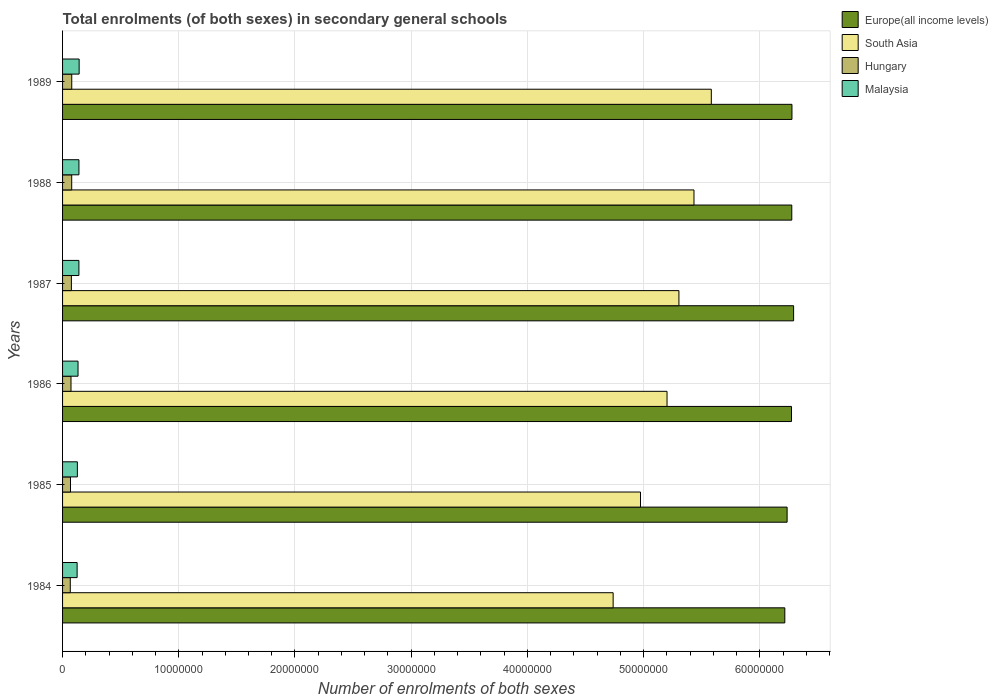What is the label of the 6th group of bars from the top?
Your response must be concise. 1984. In how many cases, is the number of bars for a given year not equal to the number of legend labels?
Offer a terse response. 0. What is the number of enrolments in secondary schools in Hungary in 1988?
Your response must be concise. 7.86e+05. Across all years, what is the maximum number of enrolments in secondary schools in South Asia?
Your answer should be compact. 5.58e+07. Across all years, what is the minimum number of enrolments in secondary schools in Malaysia?
Your answer should be compact. 1.25e+06. In which year was the number of enrolments in secondary schools in Malaysia maximum?
Keep it short and to the point. 1989. In which year was the number of enrolments in secondary schools in Hungary minimum?
Offer a terse response. 1984. What is the total number of enrolments in secondary schools in South Asia in the graph?
Keep it short and to the point. 3.12e+08. What is the difference between the number of enrolments in secondary schools in Hungary in 1984 and that in 1988?
Provide a short and direct response. -1.23e+05. What is the difference between the number of enrolments in secondary schools in Europe(all income levels) in 1987 and the number of enrolments in secondary schools in South Asia in 1985?
Make the answer very short. 1.32e+07. What is the average number of enrolments in secondary schools in Malaysia per year?
Your answer should be compact. 1.35e+06. In the year 1984, what is the difference between the number of enrolments in secondary schools in Hungary and number of enrolments in secondary schools in Europe(all income levels)?
Provide a succinct answer. -6.15e+07. What is the ratio of the number of enrolments in secondary schools in South Asia in 1984 to that in 1988?
Your answer should be compact. 0.87. Is the number of enrolments in secondary schools in South Asia in 1984 less than that in 1987?
Offer a terse response. Yes. What is the difference between the highest and the second highest number of enrolments in secondary schools in Hungary?
Your response must be concise. 3488. What is the difference between the highest and the lowest number of enrolments in secondary schools in Europe(all income levels)?
Your response must be concise. 7.57e+05. Is the sum of the number of enrolments in secondary schools in Malaysia in 1985 and 1989 greater than the maximum number of enrolments in secondary schools in Hungary across all years?
Provide a short and direct response. Yes. Is it the case that in every year, the sum of the number of enrolments in secondary schools in Europe(all income levels) and number of enrolments in secondary schools in South Asia is greater than the sum of number of enrolments in secondary schools in Hungary and number of enrolments in secondary schools in Malaysia?
Your answer should be compact. No. What does the 3rd bar from the top in 1988 represents?
Your answer should be very brief. South Asia. What does the 3rd bar from the bottom in 1989 represents?
Provide a succinct answer. Hungary. Is it the case that in every year, the sum of the number of enrolments in secondary schools in Hungary and number of enrolments in secondary schools in Europe(all income levels) is greater than the number of enrolments in secondary schools in Malaysia?
Make the answer very short. Yes. Where does the legend appear in the graph?
Your answer should be very brief. Top right. How many legend labels are there?
Your answer should be very brief. 4. How are the legend labels stacked?
Give a very brief answer. Vertical. What is the title of the graph?
Give a very brief answer. Total enrolments (of both sexes) in secondary general schools. Does "Romania" appear as one of the legend labels in the graph?
Make the answer very short. No. What is the label or title of the X-axis?
Provide a succinct answer. Number of enrolments of both sexes. What is the Number of enrolments of both sexes of Europe(all income levels) in 1984?
Give a very brief answer. 6.22e+07. What is the Number of enrolments of both sexes of South Asia in 1984?
Keep it short and to the point. 4.74e+07. What is the Number of enrolments of both sexes of Hungary in 1984?
Make the answer very short. 6.63e+05. What is the Number of enrolments of both sexes of Malaysia in 1984?
Your response must be concise. 1.25e+06. What is the Number of enrolments of both sexes of Europe(all income levels) in 1985?
Provide a succinct answer. 6.24e+07. What is the Number of enrolments of both sexes in South Asia in 1985?
Provide a succinct answer. 4.97e+07. What is the Number of enrolments of both sexes in Hungary in 1985?
Offer a terse response. 6.83e+05. What is the Number of enrolments of both sexes in Malaysia in 1985?
Give a very brief answer. 1.27e+06. What is the Number of enrolments of both sexes in Europe(all income levels) in 1986?
Provide a short and direct response. 6.27e+07. What is the Number of enrolments of both sexes in South Asia in 1986?
Provide a short and direct response. 5.20e+07. What is the Number of enrolments of both sexes of Hungary in 1986?
Your response must be concise. 7.26e+05. What is the Number of enrolments of both sexes in Malaysia in 1986?
Make the answer very short. 1.33e+06. What is the Number of enrolments of both sexes in Europe(all income levels) in 1987?
Your response must be concise. 6.29e+07. What is the Number of enrolments of both sexes of South Asia in 1987?
Keep it short and to the point. 5.30e+07. What is the Number of enrolments of both sexes of Hungary in 1987?
Offer a terse response. 7.60e+05. What is the Number of enrolments of both sexes of Malaysia in 1987?
Offer a terse response. 1.41e+06. What is the Number of enrolments of both sexes in Europe(all income levels) in 1988?
Your answer should be compact. 6.28e+07. What is the Number of enrolments of both sexes of South Asia in 1988?
Make the answer very short. 5.43e+07. What is the Number of enrolments of both sexes of Hungary in 1988?
Your answer should be compact. 7.86e+05. What is the Number of enrolments of both sexes of Malaysia in 1988?
Keep it short and to the point. 1.41e+06. What is the Number of enrolments of both sexes of Europe(all income levels) in 1989?
Make the answer very short. 6.28e+07. What is the Number of enrolments of both sexes of South Asia in 1989?
Your response must be concise. 5.58e+07. What is the Number of enrolments of both sexes of Hungary in 1989?
Offer a terse response. 7.90e+05. What is the Number of enrolments of both sexes of Malaysia in 1989?
Your answer should be compact. 1.43e+06. Across all years, what is the maximum Number of enrolments of both sexes in Europe(all income levels)?
Provide a succinct answer. 6.29e+07. Across all years, what is the maximum Number of enrolments of both sexes in South Asia?
Your response must be concise. 5.58e+07. Across all years, what is the maximum Number of enrolments of both sexes of Hungary?
Ensure brevity in your answer.  7.90e+05. Across all years, what is the maximum Number of enrolments of both sexes of Malaysia?
Offer a terse response. 1.43e+06. Across all years, what is the minimum Number of enrolments of both sexes of Europe(all income levels)?
Provide a succinct answer. 6.22e+07. Across all years, what is the minimum Number of enrolments of both sexes of South Asia?
Keep it short and to the point. 4.74e+07. Across all years, what is the minimum Number of enrolments of both sexes of Hungary?
Your response must be concise. 6.63e+05. Across all years, what is the minimum Number of enrolments of both sexes of Malaysia?
Offer a very short reply. 1.25e+06. What is the total Number of enrolments of both sexes of Europe(all income levels) in the graph?
Offer a terse response. 3.76e+08. What is the total Number of enrolments of both sexes of South Asia in the graph?
Offer a terse response. 3.12e+08. What is the total Number of enrolments of both sexes of Hungary in the graph?
Your answer should be compact. 4.41e+06. What is the total Number of enrolments of both sexes of Malaysia in the graph?
Ensure brevity in your answer.  8.10e+06. What is the difference between the Number of enrolments of both sexes of Europe(all income levels) in 1984 and that in 1985?
Offer a terse response. -1.97e+05. What is the difference between the Number of enrolments of both sexes of South Asia in 1984 and that in 1985?
Your answer should be compact. -2.36e+06. What is the difference between the Number of enrolments of both sexes of Hungary in 1984 and that in 1985?
Ensure brevity in your answer.  -1.94e+04. What is the difference between the Number of enrolments of both sexes in Malaysia in 1984 and that in 1985?
Your answer should be very brief. -2.15e+04. What is the difference between the Number of enrolments of both sexes of Europe(all income levels) in 1984 and that in 1986?
Your answer should be compact. -5.74e+05. What is the difference between the Number of enrolments of both sexes of South Asia in 1984 and that in 1986?
Your answer should be very brief. -4.64e+06. What is the difference between the Number of enrolments of both sexes in Hungary in 1984 and that in 1986?
Make the answer very short. -6.28e+04. What is the difference between the Number of enrolments of both sexes of Malaysia in 1984 and that in 1986?
Make the answer very short. -7.76e+04. What is the difference between the Number of enrolments of both sexes in Europe(all income levels) in 1984 and that in 1987?
Offer a terse response. -7.57e+05. What is the difference between the Number of enrolments of both sexes in South Asia in 1984 and that in 1987?
Give a very brief answer. -5.66e+06. What is the difference between the Number of enrolments of both sexes of Hungary in 1984 and that in 1987?
Offer a terse response. -9.64e+04. What is the difference between the Number of enrolments of both sexes of Malaysia in 1984 and that in 1987?
Provide a succinct answer. -1.53e+05. What is the difference between the Number of enrolments of both sexes in Europe(all income levels) in 1984 and that in 1988?
Provide a succinct answer. -5.99e+05. What is the difference between the Number of enrolments of both sexes in South Asia in 1984 and that in 1988?
Offer a very short reply. -6.96e+06. What is the difference between the Number of enrolments of both sexes in Hungary in 1984 and that in 1988?
Your answer should be compact. -1.23e+05. What is the difference between the Number of enrolments of both sexes in Malaysia in 1984 and that in 1988?
Your response must be concise. -1.56e+05. What is the difference between the Number of enrolments of both sexes of Europe(all income levels) in 1984 and that in 1989?
Give a very brief answer. -6.14e+05. What is the difference between the Number of enrolments of both sexes of South Asia in 1984 and that in 1989?
Give a very brief answer. -8.45e+06. What is the difference between the Number of enrolments of both sexes of Hungary in 1984 and that in 1989?
Your answer should be very brief. -1.26e+05. What is the difference between the Number of enrolments of both sexes in Malaysia in 1984 and that in 1989?
Ensure brevity in your answer.  -1.73e+05. What is the difference between the Number of enrolments of both sexes of Europe(all income levels) in 1985 and that in 1986?
Your answer should be compact. -3.78e+05. What is the difference between the Number of enrolments of both sexes in South Asia in 1985 and that in 1986?
Make the answer very short. -2.28e+06. What is the difference between the Number of enrolments of both sexes of Hungary in 1985 and that in 1986?
Your answer should be very brief. -4.35e+04. What is the difference between the Number of enrolments of both sexes of Malaysia in 1985 and that in 1986?
Provide a short and direct response. -5.61e+04. What is the difference between the Number of enrolments of both sexes of Europe(all income levels) in 1985 and that in 1987?
Offer a very short reply. -5.60e+05. What is the difference between the Number of enrolments of both sexes of South Asia in 1985 and that in 1987?
Your response must be concise. -3.31e+06. What is the difference between the Number of enrolments of both sexes in Hungary in 1985 and that in 1987?
Provide a succinct answer. -7.71e+04. What is the difference between the Number of enrolments of both sexes in Malaysia in 1985 and that in 1987?
Your answer should be very brief. -1.32e+05. What is the difference between the Number of enrolments of both sexes in Europe(all income levels) in 1985 and that in 1988?
Offer a very short reply. -4.03e+05. What is the difference between the Number of enrolments of both sexes in South Asia in 1985 and that in 1988?
Your answer should be very brief. -4.60e+06. What is the difference between the Number of enrolments of both sexes in Hungary in 1985 and that in 1988?
Your response must be concise. -1.04e+05. What is the difference between the Number of enrolments of both sexes in Malaysia in 1985 and that in 1988?
Your answer should be compact. -1.34e+05. What is the difference between the Number of enrolments of both sexes in Europe(all income levels) in 1985 and that in 1989?
Keep it short and to the point. -4.17e+05. What is the difference between the Number of enrolments of both sexes of South Asia in 1985 and that in 1989?
Provide a succinct answer. -6.09e+06. What is the difference between the Number of enrolments of both sexes in Hungary in 1985 and that in 1989?
Ensure brevity in your answer.  -1.07e+05. What is the difference between the Number of enrolments of both sexes of Malaysia in 1985 and that in 1989?
Your response must be concise. -1.52e+05. What is the difference between the Number of enrolments of both sexes in Europe(all income levels) in 1986 and that in 1987?
Your answer should be compact. -1.82e+05. What is the difference between the Number of enrolments of both sexes in South Asia in 1986 and that in 1987?
Keep it short and to the point. -1.02e+06. What is the difference between the Number of enrolments of both sexes in Hungary in 1986 and that in 1987?
Your response must be concise. -3.36e+04. What is the difference between the Number of enrolments of both sexes in Malaysia in 1986 and that in 1987?
Provide a short and direct response. -7.59e+04. What is the difference between the Number of enrolments of both sexes of Europe(all income levels) in 1986 and that in 1988?
Make the answer very short. -2.49e+04. What is the difference between the Number of enrolments of both sexes in South Asia in 1986 and that in 1988?
Your answer should be compact. -2.32e+06. What is the difference between the Number of enrolments of both sexes of Hungary in 1986 and that in 1988?
Offer a terse response. -6.00e+04. What is the difference between the Number of enrolments of both sexes in Malaysia in 1986 and that in 1988?
Make the answer very short. -7.83e+04. What is the difference between the Number of enrolments of both sexes of Europe(all income levels) in 1986 and that in 1989?
Your response must be concise. -3.92e+04. What is the difference between the Number of enrolments of both sexes of South Asia in 1986 and that in 1989?
Your answer should be very brief. -3.81e+06. What is the difference between the Number of enrolments of both sexes of Hungary in 1986 and that in 1989?
Offer a terse response. -6.35e+04. What is the difference between the Number of enrolments of both sexes of Malaysia in 1986 and that in 1989?
Offer a terse response. -9.56e+04. What is the difference between the Number of enrolments of both sexes of Europe(all income levels) in 1987 and that in 1988?
Your answer should be very brief. 1.58e+05. What is the difference between the Number of enrolments of both sexes in South Asia in 1987 and that in 1988?
Provide a succinct answer. -1.30e+06. What is the difference between the Number of enrolments of both sexes in Hungary in 1987 and that in 1988?
Ensure brevity in your answer.  -2.64e+04. What is the difference between the Number of enrolments of both sexes in Malaysia in 1987 and that in 1988?
Provide a succinct answer. -2446. What is the difference between the Number of enrolments of both sexes in Europe(all income levels) in 1987 and that in 1989?
Offer a very short reply. 1.43e+05. What is the difference between the Number of enrolments of both sexes in South Asia in 1987 and that in 1989?
Offer a terse response. -2.79e+06. What is the difference between the Number of enrolments of both sexes of Hungary in 1987 and that in 1989?
Make the answer very short. -2.99e+04. What is the difference between the Number of enrolments of both sexes in Malaysia in 1987 and that in 1989?
Your answer should be compact. -1.97e+04. What is the difference between the Number of enrolments of both sexes of Europe(all income levels) in 1988 and that in 1989?
Give a very brief answer. -1.42e+04. What is the difference between the Number of enrolments of both sexes in South Asia in 1988 and that in 1989?
Make the answer very short. -1.49e+06. What is the difference between the Number of enrolments of both sexes of Hungary in 1988 and that in 1989?
Keep it short and to the point. -3488. What is the difference between the Number of enrolments of both sexes of Malaysia in 1988 and that in 1989?
Give a very brief answer. -1.73e+04. What is the difference between the Number of enrolments of both sexes in Europe(all income levels) in 1984 and the Number of enrolments of both sexes in South Asia in 1985?
Your answer should be compact. 1.24e+07. What is the difference between the Number of enrolments of both sexes of Europe(all income levels) in 1984 and the Number of enrolments of both sexes of Hungary in 1985?
Keep it short and to the point. 6.15e+07. What is the difference between the Number of enrolments of both sexes of Europe(all income levels) in 1984 and the Number of enrolments of both sexes of Malaysia in 1985?
Offer a terse response. 6.09e+07. What is the difference between the Number of enrolments of both sexes in South Asia in 1984 and the Number of enrolments of both sexes in Hungary in 1985?
Your answer should be compact. 4.67e+07. What is the difference between the Number of enrolments of both sexes in South Asia in 1984 and the Number of enrolments of both sexes in Malaysia in 1985?
Provide a succinct answer. 4.61e+07. What is the difference between the Number of enrolments of both sexes in Hungary in 1984 and the Number of enrolments of both sexes in Malaysia in 1985?
Provide a succinct answer. -6.11e+05. What is the difference between the Number of enrolments of both sexes of Europe(all income levels) in 1984 and the Number of enrolments of both sexes of South Asia in 1986?
Provide a succinct answer. 1.01e+07. What is the difference between the Number of enrolments of both sexes of Europe(all income levels) in 1984 and the Number of enrolments of both sexes of Hungary in 1986?
Make the answer very short. 6.14e+07. What is the difference between the Number of enrolments of both sexes of Europe(all income levels) in 1984 and the Number of enrolments of both sexes of Malaysia in 1986?
Your answer should be very brief. 6.08e+07. What is the difference between the Number of enrolments of both sexes of South Asia in 1984 and the Number of enrolments of both sexes of Hungary in 1986?
Offer a terse response. 4.67e+07. What is the difference between the Number of enrolments of both sexes in South Asia in 1984 and the Number of enrolments of both sexes in Malaysia in 1986?
Your response must be concise. 4.61e+07. What is the difference between the Number of enrolments of both sexes of Hungary in 1984 and the Number of enrolments of both sexes of Malaysia in 1986?
Offer a terse response. -6.67e+05. What is the difference between the Number of enrolments of both sexes in Europe(all income levels) in 1984 and the Number of enrolments of both sexes in South Asia in 1987?
Make the answer very short. 9.11e+06. What is the difference between the Number of enrolments of both sexes in Europe(all income levels) in 1984 and the Number of enrolments of both sexes in Hungary in 1987?
Provide a succinct answer. 6.14e+07. What is the difference between the Number of enrolments of both sexes in Europe(all income levels) in 1984 and the Number of enrolments of both sexes in Malaysia in 1987?
Provide a short and direct response. 6.07e+07. What is the difference between the Number of enrolments of both sexes of South Asia in 1984 and the Number of enrolments of both sexes of Hungary in 1987?
Your answer should be very brief. 4.66e+07. What is the difference between the Number of enrolments of both sexes in South Asia in 1984 and the Number of enrolments of both sexes in Malaysia in 1987?
Provide a succinct answer. 4.60e+07. What is the difference between the Number of enrolments of both sexes of Hungary in 1984 and the Number of enrolments of both sexes of Malaysia in 1987?
Ensure brevity in your answer.  -7.43e+05. What is the difference between the Number of enrolments of both sexes in Europe(all income levels) in 1984 and the Number of enrolments of both sexes in South Asia in 1988?
Offer a terse response. 7.82e+06. What is the difference between the Number of enrolments of both sexes in Europe(all income levels) in 1984 and the Number of enrolments of both sexes in Hungary in 1988?
Give a very brief answer. 6.14e+07. What is the difference between the Number of enrolments of both sexes of Europe(all income levels) in 1984 and the Number of enrolments of both sexes of Malaysia in 1988?
Offer a terse response. 6.07e+07. What is the difference between the Number of enrolments of both sexes of South Asia in 1984 and the Number of enrolments of both sexes of Hungary in 1988?
Your answer should be very brief. 4.66e+07. What is the difference between the Number of enrolments of both sexes in South Asia in 1984 and the Number of enrolments of both sexes in Malaysia in 1988?
Provide a short and direct response. 4.60e+07. What is the difference between the Number of enrolments of both sexes of Hungary in 1984 and the Number of enrolments of both sexes of Malaysia in 1988?
Your answer should be very brief. -7.45e+05. What is the difference between the Number of enrolments of both sexes in Europe(all income levels) in 1984 and the Number of enrolments of both sexes in South Asia in 1989?
Keep it short and to the point. 6.33e+06. What is the difference between the Number of enrolments of both sexes in Europe(all income levels) in 1984 and the Number of enrolments of both sexes in Hungary in 1989?
Ensure brevity in your answer.  6.14e+07. What is the difference between the Number of enrolments of both sexes in Europe(all income levels) in 1984 and the Number of enrolments of both sexes in Malaysia in 1989?
Your response must be concise. 6.07e+07. What is the difference between the Number of enrolments of both sexes of South Asia in 1984 and the Number of enrolments of both sexes of Hungary in 1989?
Provide a short and direct response. 4.66e+07. What is the difference between the Number of enrolments of both sexes in South Asia in 1984 and the Number of enrolments of both sexes in Malaysia in 1989?
Ensure brevity in your answer.  4.60e+07. What is the difference between the Number of enrolments of both sexes of Hungary in 1984 and the Number of enrolments of both sexes of Malaysia in 1989?
Keep it short and to the point. -7.63e+05. What is the difference between the Number of enrolments of both sexes in Europe(all income levels) in 1985 and the Number of enrolments of both sexes in South Asia in 1986?
Provide a short and direct response. 1.03e+07. What is the difference between the Number of enrolments of both sexes in Europe(all income levels) in 1985 and the Number of enrolments of both sexes in Hungary in 1986?
Give a very brief answer. 6.16e+07. What is the difference between the Number of enrolments of both sexes in Europe(all income levels) in 1985 and the Number of enrolments of both sexes in Malaysia in 1986?
Your answer should be very brief. 6.10e+07. What is the difference between the Number of enrolments of both sexes of South Asia in 1985 and the Number of enrolments of both sexes of Hungary in 1986?
Provide a short and direct response. 4.90e+07. What is the difference between the Number of enrolments of both sexes of South Asia in 1985 and the Number of enrolments of both sexes of Malaysia in 1986?
Make the answer very short. 4.84e+07. What is the difference between the Number of enrolments of both sexes in Hungary in 1985 and the Number of enrolments of both sexes in Malaysia in 1986?
Offer a very short reply. -6.48e+05. What is the difference between the Number of enrolments of both sexes in Europe(all income levels) in 1985 and the Number of enrolments of both sexes in South Asia in 1987?
Offer a very short reply. 9.31e+06. What is the difference between the Number of enrolments of both sexes in Europe(all income levels) in 1985 and the Number of enrolments of both sexes in Hungary in 1987?
Provide a short and direct response. 6.16e+07. What is the difference between the Number of enrolments of both sexes of Europe(all income levels) in 1985 and the Number of enrolments of both sexes of Malaysia in 1987?
Make the answer very short. 6.09e+07. What is the difference between the Number of enrolments of both sexes of South Asia in 1985 and the Number of enrolments of both sexes of Hungary in 1987?
Ensure brevity in your answer.  4.90e+07. What is the difference between the Number of enrolments of both sexes in South Asia in 1985 and the Number of enrolments of both sexes in Malaysia in 1987?
Give a very brief answer. 4.83e+07. What is the difference between the Number of enrolments of both sexes of Hungary in 1985 and the Number of enrolments of both sexes of Malaysia in 1987?
Your answer should be very brief. -7.23e+05. What is the difference between the Number of enrolments of both sexes of Europe(all income levels) in 1985 and the Number of enrolments of both sexes of South Asia in 1988?
Keep it short and to the point. 8.01e+06. What is the difference between the Number of enrolments of both sexes of Europe(all income levels) in 1985 and the Number of enrolments of both sexes of Hungary in 1988?
Keep it short and to the point. 6.16e+07. What is the difference between the Number of enrolments of both sexes of Europe(all income levels) in 1985 and the Number of enrolments of both sexes of Malaysia in 1988?
Give a very brief answer. 6.09e+07. What is the difference between the Number of enrolments of both sexes of South Asia in 1985 and the Number of enrolments of both sexes of Hungary in 1988?
Provide a short and direct response. 4.90e+07. What is the difference between the Number of enrolments of both sexes in South Asia in 1985 and the Number of enrolments of both sexes in Malaysia in 1988?
Offer a terse response. 4.83e+07. What is the difference between the Number of enrolments of both sexes of Hungary in 1985 and the Number of enrolments of both sexes of Malaysia in 1988?
Provide a succinct answer. -7.26e+05. What is the difference between the Number of enrolments of both sexes in Europe(all income levels) in 1985 and the Number of enrolments of both sexes in South Asia in 1989?
Ensure brevity in your answer.  6.52e+06. What is the difference between the Number of enrolments of both sexes in Europe(all income levels) in 1985 and the Number of enrolments of both sexes in Hungary in 1989?
Give a very brief answer. 6.16e+07. What is the difference between the Number of enrolments of both sexes of Europe(all income levels) in 1985 and the Number of enrolments of both sexes of Malaysia in 1989?
Provide a succinct answer. 6.09e+07. What is the difference between the Number of enrolments of both sexes in South Asia in 1985 and the Number of enrolments of both sexes in Hungary in 1989?
Keep it short and to the point. 4.89e+07. What is the difference between the Number of enrolments of both sexes in South Asia in 1985 and the Number of enrolments of both sexes in Malaysia in 1989?
Provide a succinct answer. 4.83e+07. What is the difference between the Number of enrolments of both sexes of Hungary in 1985 and the Number of enrolments of both sexes of Malaysia in 1989?
Keep it short and to the point. -7.43e+05. What is the difference between the Number of enrolments of both sexes of Europe(all income levels) in 1986 and the Number of enrolments of both sexes of South Asia in 1987?
Ensure brevity in your answer.  9.69e+06. What is the difference between the Number of enrolments of both sexes of Europe(all income levels) in 1986 and the Number of enrolments of both sexes of Hungary in 1987?
Provide a succinct answer. 6.20e+07. What is the difference between the Number of enrolments of both sexes in Europe(all income levels) in 1986 and the Number of enrolments of both sexes in Malaysia in 1987?
Provide a succinct answer. 6.13e+07. What is the difference between the Number of enrolments of both sexes of South Asia in 1986 and the Number of enrolments of both sexes of Hungary in 1987?
Provide a succinct answer. 5.13e+07. What is the difference between the Number of enrolments of both sexes of South Asia in 1986 and the Number of enrolments of both sexes of Malaysia in 1987?
Keep it short and to the point. 5.06e+07. What is the difference between the Number of enrolments of both sexes in Hungary in 1986 and the Number of enrolments of both sexes in Malaysia in 1987?
Make the answer very short. -6.80e+05. What is the difference between the Number of enrolments of both sexes of Europe(all income levels) in 1986 and the Number of enrolments of both sexes of South Asia in 1988?
Offer a very short reply. 8.39e+06. What is the difference between the Number of enrolments of both sexes in Europe(all income levels) in 1986 and the Number of enrolments of both sexes in Hungary in 1988?
Provide a succinct answer. 6.19e+07. What is the difference between the Number of enrolments of both sexes in Europe(all income levels) in 1986 and the Number of enrolments of both sexes in Malaysia in 1988?
Provide a succinct answer. 6.13e+07. What is the difference between the Number of enrolments of both sexes of South Asia in 1986 and the Number of enrolments of both sexes of Hungary in 1988?
Keep it short and to the point. 5.12e+07. What is the difference between the Number of enrolments of both sexes in South Asia in 1986 and the Number of enrolments of both sexes in Malaysia in 1988?
Ensure brevity in your answer.  5.06e+07. What is the difference between the Number of enrolments of both sexes in Hungary in 1986 and the Number of enrolments of both sexes in Malaysia in 1988?
Your response must be concise. -6.82e+05. What is the difference between the Number of enrolments of both sexes of Europe(all income levels) in 1986 and the Number of enrolments of both sexes of South Asia in 1989?
Give a very brief answer. 6.90e+06. What is the difference between the Number of enrolments of both sexes of Europe(all income levels) in 1986 and the Number of enrolments of both sexes of Hungary in 1989?
Your answer should be compact. 6.19e+07. What is the difference between the Number of enrolments of both sexes in Europe(all income levels) in 1986 and the Number of enrolments of both sexes in Malaysia in 1989?
Ensure brevity in your answer.  6.13e+07. What is the difference between the Number of enrolments of both sexes in South Asia in 1986 and the Number of enrolments of both sexes in Hungary in 1989?
Offer a very short reply. 5.12e+07. What is the difference between the Number of enrolments of both sexes in South Asia in 1986 and the Number of enrolments of both sexes in Malaysia in 1989?
Provide a short and direct response. 5.06e+07. What is the difference between the Number of enrolments of both sexes of Hungary in 1986 and the Number of enrolments of both sexes of Malaysia in 1989?
Provide a succinct answer. -7.00e+05. What is the difference between the Number of enrolments of both sexes of Europe(all income levels) in 1987 and the Number of enrolments of both sexes of South Asia in 1988?
Ensure brevity in your answer.  8.57e+06. What is the difference between the Number of enrolments of both sexes in Europe(all income levels) in 1987 and the Number of enrolments of both sexes in Hungary in 1988?
Your response must be concise. 6.21e+07. What is the difference between the Number of enrolments of both sexes in Europe(all income levels) in 1987 and the Number of enrolments of both sexes in Malaysia in 1988?
Offer a terse response. 6.15e+07. What is the difference between the Number of enrolments of both sexes in South Asia in 1987 and the Number of enrolments of both sexes in Hungary in 1988?
Provide a succinct answer. 5.23e+07. What is the difference between the Number of enrolments of both sexes of South Asia in 1987 and the Number of enrolments of both sexes of Malaysia in 1988?
Make the answer very short. 5.16e+07. What is the difference between the Number of enrolments of both sexes in Hungary in 1987 and the Number of enrolments of both sexes in Malaysia in 1988?
Your response must be concise. -6.49e+05. What is the difference between the Number of enrolments of both sexes of Europe(all income levels) in 1987 and the Number of enrolments of both sexes of South Asia in 1989?
Your answer should be compact. 7.08e+06. What is the difference between the Number of enrolments of both sexes of Europe(all income levels) in 1987 and the Number of enrolments of both sexes of Hungary in 1989?
Ensure brevity in your answer.  6.21e+07. What is the difference between the Number of enrolments of both sexes in Europe(all income levels) in 1987 and the Number of enrolments of both sexes in Malaysia in 1989?
Provide a short and direct response. 6.15e+07. What is the difference between the Number of enrolments of both sexes in South Asia in 1987 and the Number of enrolments of both sexes in Hungary in 1989?
Give a very brief answer. 5.23e+07. What is the difference between the Number of enrolments of both sexes of South Asia in 1987 and the Number of enrolments of both sexes of Malaysia in 1989?
Offer a very short reply. 5.16e+07. What is the difference between the Number of enrolments of both sexes in Hungary in 1987 and the Number of enrolments of both sexes in Malaysia in 1989?
Offer a terse response. -6.66e+05. What is the difference between the Number of enrolments of both sexes in Europe(all income levels) in 1988 and the Number of enrolments of both sexes in South Asia in 1989?
Make the answer very short. 6.92e+06. What is the difference between the Number of enrolments of both sexes in Europe(all income levels) in 1988 and the Number of enrolments of both sexes in Hungary in 1989?
Your response must be concise. 6.20e+07. What is the difference between the Number of enrolments of both sexes in Europe(all income levels) in 1988 and the Number of enrolments of both sexes in Malaysia in 1989?
Your response must be concise. 6.13e+07. What is the difference between the Number of enrolments of both sexes of South Asia in 1988 and the Number of enrolments of both sexes of Hungary in 1989?
Provide a short and direct response. 5.35e+07. What is the difference between the Number of enrolments of both sexes of South Asia in 1988 and the Number of enrolments of both sexes of Malaysia in 1989?
Offer a very short reply. 5.29e+07. What is the difference between the Number of enrolments of both sexes of Hungary in 1988 and the Number of enrolments of both sexes of Malaysia in 1989?
Offer a very short reply. -6.40e+05. What is the average Number of enrolments of both sexes in Europe(all income levels) per year?
Make the answer very short. 6.26e+07. What is the average Number of enrolments of both sexes in South Asia per year?
Make the answer very short. 5.21e+07. What is the average Number of enrolments of both sexes in Hungary per year?
Make the answer very short. 7.35e+05. What is the average Number of enrolments of both sexes in Malaysia per year?
Your answer should be very brief. 1.35e+06. In the year 1984, what is the difference between the Number of enrolments of both sexes in Europe(all income levels) and Number of enrolments of both sexes in South Asia?
Make the answer very short. 1.48e+07. In the year 1984, what is the difference between the Number of enrolments of both sexes in Europe(all income levels) and Number of enrolments of both sexes in Hungary?
Offer a terse response. 6.15e+07. In the year 1984, what is the difference between the Number of enrolments of both sexes of Europe(all income levels) and Number of enrolments of both sexes of Malaysia?
Offer a terse response. 6.09e+07. In the year 1984, what is the difference between the Number of enrolments of both sexes of South Asia and Number of enrolments of both sexes of Hungary?
Make the answer very short. 4.67e+07. In the year 1984, what is the difference between the Number of enrolments of both sexes in South Asia and Number of enrolments of both sexes in Malaysia?
Make the answer very short. 4.61e+07. In the year 1984, what is the difference between the Number of enrolments of both sexes of Hungary and Number of enrolments of both sexes of Malaysia?
Offer a terse response. -5.89e+05. In the year 1985, what is the difference between the Number of enrolments of both sexes in Europe(all income levels) and Number of enrolments of both sexes in South Asia?
Offer a terse response. 1.26e+07. In the year 1985, what is the difference between the Number of enrolments of both sexes of Europe(all income levels) and Number of enrolments of both sexes of Hungary?
Provide a succinct answer. 6.17e+07. In the year 1985, what is the difference between the Number of enrolments of both sexes in Europe(all income levels) and Number of enrolments of both sexes in Malaysia?
Ensure brevity in your answer.  6.11e+07. In the year 1985, what is the difference between the Number of enrolments of both sexes of South Asia and Number of enrolments of both sexes of Hungary?
Give a very brief answer. 4.91e+07. In the year 1985, what is the difference between the Number of enrolments of both sexes in South Asia and Number of enrolments of both sexes in Malaysia?
Make the answer very short. 4.85e+07. In the year 1985, what is the difference between the Number of enrolments of both sexes of Hungary and Number of enrolments of both sexes of Malaysia?
Provide a short and direct response. -5.92e+05. In the year 1986, what is the difference between the Number of enrolments of both sexes in Europe(all income levels) and Number of enrolments of both sexes in South Asia?
Offer a very short reply. 1.07e+07. In the year 1986, what is the difference between the Number of enrolments of both sexes of Europe(all income levels) and Number of enrolments of both sexes of Hungary?
Your answer should be very brief. 6.20e+07. In the year 1986, what is the difference between the Number of enrolments of both sexes of Europe(all income levels) and Number of enrolments of both sexes of Malaysia?
Ensure brevity in your answer.  6.14e+07. In the year 1986, what is the difference between the Number of enrolments of both sexes in South Asia and Number of enrolments of both sexes in Hungary?
Offer a very short reply. 5.13e+07. In the year 1986, what is the difference between the Number of enrolments of both sexes of South Asia and Number of enrolments of both sexes of Malaysia?
Your answer should be very brief. 5.07e+07. In the year 1986, what is the difference between the Number of enrolments of both sexes of Hungary and Number of enrolments of both sexes of Malaysia?
Provide a succinct answer. -6.04e+05. In the year 1987, what is the difference between the Number of enrolments of both sexes in Europe(all income levels) and Number of enrolments of both sexes in South Asia?
Provide a short and direct response. 9.87e+06. In the year 1987, what is the difference between the Number of enrolments of both sexes in Europe(all income levels) and Number of enrolments of both sexes in Hungary?
Make the answer very short. 6.22e+07. In the year 1987, what is the difference between the Number of enrolments of both sexes in Europe(all income levels) and Number of enrolments of both sexes in Malaysia?
Your answer should be compact. 6.15e+07. In the year 1987, what is the difference between the Number of enrolments of both sexes in South Asia and Number of enrolments of both sexes in Hungary?
Your response must be concise. 5.23e+07. In the year 1987, what is the difference between the Number of enrolments of both sexes of South Asia and Number of enrolments of both sexes of Malaysia?
Give a very brief answer. 5.16e+07. In the year 1987, what is the difference between the Number of enrolments of both sexes in Hungary and Number of enrolments of both sexes in Malaysia?
Your answer should be compact. -6.46e+05. In the year 1988, what is the difference between the Number of enrolments of both sexes in Europe(all income levels) and Number of enrolments of both sexes in South Asia?
Keep it short and to the point. 8.42e+06. In the year 1988, what is the difference between the Number of enrolments of both sexes in Europe(all income levels) and Number of enrolments of both sexes in Hungary?
Provide a succinct answer. 6.20e+07. In the year 1988, what is the difference between the Number of enrolments of both sexes in Europe(all income levels) and Number of enrolments of both sexes in Malaysia?
Give a very brief answer. 6.13e+07. In the year 1988, what is the difference between the Number of enrolments of both sexes in South Asia and Number of enrolments of both sexes in Hungary?
Your answer should be very brief. 5.36e+07. In the year 1988, what is the difference between the Number of enrolments of both sexes in South Asia and Number of enrolments of both sexes in Malaysia?
Offer a very short reply. 5.29e+07. In the year 1988, what is the difference between the Number of enrolments of both sexes of Hungary and Number of enrolments of both sexes of Malaysia?
Offer a terse response. -6.22e+05. In the year 1989, what is the difference between the Number of enrolments of both sexes of Europe(all income levels) and Number of enrolments of both sexes of South Asia?
Make the answer very short. 6.94e+06. In the year 1989, what is the difference between the Number of enrolments of both sexes in Europe(all income levels) and Number of enrolments of both sexes in Hungary?
Offer a very short reply. 6.20e+07. In the year 1989, what is the difference between the Number of enrolments of both sexes in Europe(all income levels) and Number of enrolments of both sexes in Malaysia?
Offer a very short reply. 6.13e+07. In the year 1989, what is the difference between the Number of enrolments of both sexes of South Asia and Number of enrolments of both sexes of Hungary?
Offer a terse response. 5.50e+07. In the year 1989, what is the difference between the Number of enrolments of both sexes of South Asia and Number of enrolments of both sexes of Malaysia?
Offer a very short reply. 5.44e+07. In the year 1989, what is the difference between the Number of enrolments of both sexes of Hungary and Number of enrolments of both sexes of Malaysia?
Provide a short and direct response. -6.36e+05. What is the ratio of the Number of enrolments of both sexes in Europe(all income levels) in 1984 to that in 1985?
Provide a short and direct response. 1. What is the ratio of the Number of enrolments of both sexes in South Asia in 1984 to that in 1985?
Provide a short and direct response. 0.95. What is the ratio of the Number of enrolments of both sexes of Hungary in 1984 to that in 1985?
Your answer should be compact. 0.97. What is the ratio of the Number of enrolments of both sexes of Malaysia in 1984 to that in 1985?
Keep it short and to the point. 0.98. What is the ratio of the Number of enrolments of both sexes in South Asia in 1984 to that in 1986?
Make the answer very short. 0.91. What is the ratio of the Number of enrolments of both sexes in Hungary in 1984 to that in 1986?
Provide a succinct answer. 0.91. What is the ratio of the Number of enrolments of both sexes in Malaysia in 1984 to that in 1986?
Your answer should be compact. 0.94. What is the ratio of the Number of enrolments of both sexes of South Asia in 1984 to that in 1987?
Offer a very short reply. 0.89. What is the ratio of the Number of enrolments of both sexes in Hungary in 1984 to that in 1987?
Give a very brief answer. 0.87. What is the ratio of the Number of enrolments of both sexes of Malaysia in 1984 to that in 1987?
Keep it short and to the point. 0.89. What is the ratio of the Number of enrolments of both sexes of Europe(all income levels) in 1984 to that in 1988?
Your answer should be very brief. 0.99. What is the ratio of the Number of enrolments of both sexes in South Asia in 1984 to that in 1988?
Keep it short and to the point. 0.87. What is the ratio of the Number of enrolments of both sexes in Hungary in 1984 to that in 1988?
Ensure brevity in your answer.  0.84. What is the ratio of the Number of enrolments of both sexes in Malaysia in 1984 to that in 1988?
Keep it short and to the point. 0.89. What is the ratio of the Number of enrolments of both sexes in Europe(all income levels) in 1984 to that in 1989?
Make the answer very short. 0.99. What is the ratio of the Number of enrolments of both sexes in South Asia in 1984 to that in 1989?
Give a very brief answer. 0.85. What is the ratio of the Number of enrolments of both sexes in Hungary in 1984 to that in 1989?
Ensure brevity in your answer.  0.84. What is the ratio of the Number of enrolments of both sexes of Malaysia in 1984 to that in 1989?
Your answer should be very brief. 0.88. What is the ratio of the Number of enrolments of both sexes of Europe(all income levels) in 1985 to that in 1986?
Give a very brief answer. 0.99. What is the ratio of the Number of enrolments of both sexes in South Asia in 1985 to that in 1986?
Keep it short and to the point. 0.96. What is the ratio of the Number of enrolments of both sexes of Hungary in 1985 to that in 1986?
Offer a terse response. 0.94. What is the ratio of the Number of enrolments of both sexes of Malaysia in 1985 to that in 1986?
Your answer should be compact. 0.96. What is the ratio of the Number of enrolments of both sexes of South Asia in 1985 to that in 1987?
Ensure brevity in your answer.  0.94. What is the ratio of the Number of enrolments of both sexes of Hungary in 1985 to that in 1987?
Offer a terse response. 0.9. What is the ratio of the Number of enrolments of both sexes in Malaysia in 1985 to that in 1987?
Your answer should be very brief. 0.91. What is the ratio of the Number of enrolments of both sexes of South Asia in 1985 to that in 1988?
Provide a succinct answer. 0.92. What is the ratio of the Number of enrolments of both sexes in Hungary in 1985 to that in 1988?
Offer a very short reply. 0.87. What is the ratio of the Number of enrolments of both sexes of Malaysia in 1985 to that in 1988?
Provide a succinct answer. 0.9. What is the ratio of the Number of enrolments of both sexes of Europe(all income levels) in 1985 to that in 1989?
Offer a very short reply. 0.99. What is the ratio of the Number of enrolments of both sexes of South Asia in 1985 to that in 1989?
Offer a terse response. 0.89. What is the ratio of the Number of enrolments of both sexes in Hungary in 1985 to that in 1989?
Give a very brief answer. 0.86. What is the ratio of the Number of enrolments of both sexes of Malaysia in 1985 to that in 1989?
Keep it short and to the point. 0.89. What is the ratio of the Number of enrolments of both sexes in Europe(all income levels) in 1986 to that in 1987?
Offer a very short reply. 1. What is the ratio of the Number of enrolments of both sexes in South Asia in 1986 to that in 1987?
Keep it short and to the point. 0.98. What is the ratio of the Number of enrolments of both sexes of Hungary in 1986 to that in 1987?
Make the answer very short. 0.96. What is the ratio of the Number of enrolments of both sexes in Malaysia in 1986 to that in 1987?
Provide a succinct answer. 0.95. What is the ratio of the Number of enrolments of both sexes of South Asia in 1986 to that in 1988?
Give a very brief answer. 0.96. What is the ratio of the Number of enrolments of both sexes of Hungary in 1986 to that in 1988?
Give a very brief answer. 0.92. What is the ratio of the Number of enrolments of both sexes of Malaysia in 1986 to that in 1988?
Your answer should be compact. 0.94. What is the ratio of the Number of enrolments of both sexes of Europe(all income levels) in 1986 to that in 1989?
Ensure brevity in your answer.  1. What is the ratio of the Number of enrolments of both sexes in South Asia in 1986 to that in 1989?
Your answer should be very brief. 0.93. What is the ratio of the Number of enrolments of both sexes of Hungary in 1986 to that in 1989?
Ensure brevity in your answer.  0.92. What is the ratio of the Number of enrolments of both sexes of Malaysia in 1986 to that in 1989?
Give a very brief answer. 0.93. What is the ratio of the Number of enrolments of both sexes in South Asia in 1987 to that in 1988?
Keep it short and to the point. 0.98. What is the ratio of the Number of enrolments of both sexes of Hungary in 1987 to that in 1988?
Give a very brief answer. 0.97. What is the ratio of the Number of enrolments of both sexes in South Asia in 1987 to that in 1989?
Give a very brief answer. 0.95. What is the ratio of the Number of enrolments of both sexes of Hungary in 1987 to that in 1989?
Give a very brief answer. 0.96. What is the ratio of the Number of enrolments of both sexes of Malaysia in 1987 to that in 1989?
Keep it short and to the point. 0.99. What is the ratio of the Number of enrolments of both sexes of Europe(all income levels) in 1988 to that in 1989?
Provide a short and direct response. 1. What is the ratio of the Number of enrolments of both sexes of South Asia in 1988 to that in 1989?
Give a very brief answer. 0.97. What is the ratio of the Number of enrolments of both sexes of Hungary in 1988 to that in 1989?
Keep it short and to the point. 1. What is the ratio of the Number of enrolments of both sexes of Malaysia in 1988 to that in 1989?
Provide a short and direct response. 0.99. What is the difference between the highest and the second highest Number of enrolments of both sexes in Europe(all income levels)?
Keep it short and to the point. 1.43e+05. What is the difference between the highest and the second highest Number of enrolments of both sexes in South Asia?
Your answer should be very brief. 1.49e+06. What is the difference between the highest and the second highest Number of enrolments of both sexes in Hungary?
Offer a very short reply. 3488. What is the difference between the highest and the second highest Number of enrolments of both sexes of Malaysia?
Make the answer very short. 1.73e+04. What is the difference between the highest and the lowest Number of enrolments of both sexes in Europe(all income levels)?
Your answer should be compact. 7.57e+05. What is the difference between the highest and the lowest Number of enrolments of both sexes in South Asia?
Keep it short and to the point. 8.45e+06. What is the difference between the highest and the lowest Number of enrolments of both sexes of Hungary?
Your answer should be very brief. 1.26e+05. What is the difference between the highest and the lowest Number of enrolments of both sexes of Malaysia?
Provide a short and direct response. 1.73e+05. 